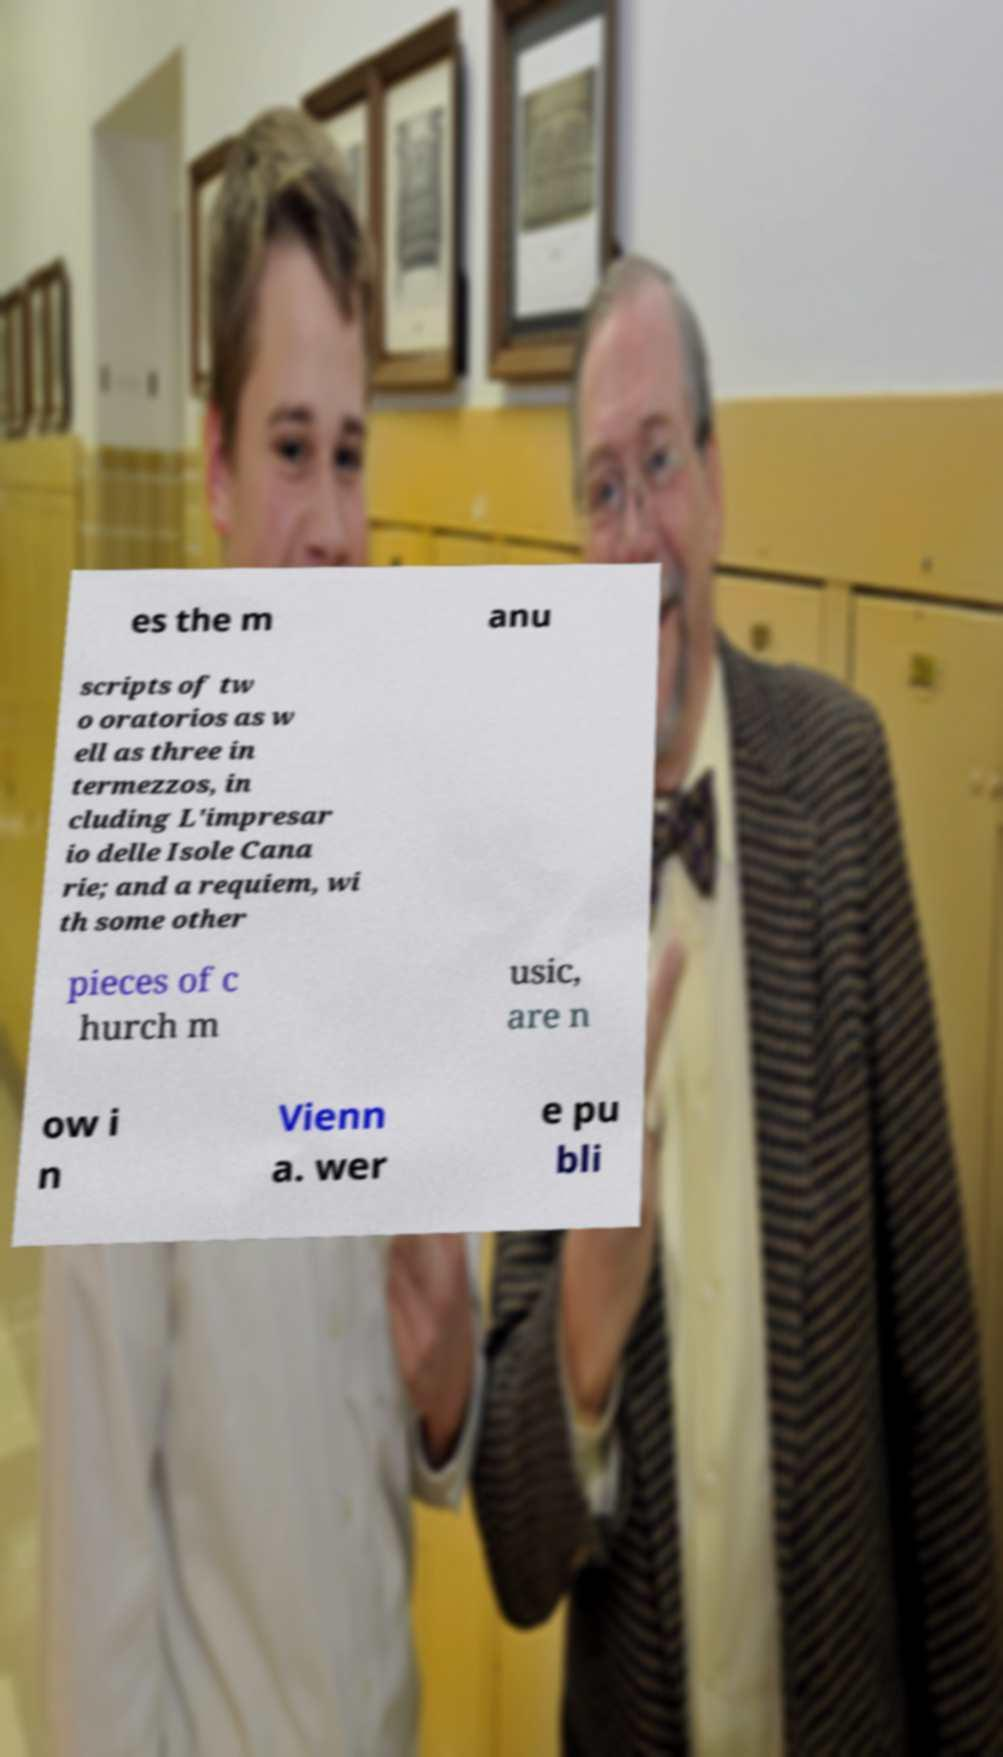Could you assist in decoding the text presented in this image and type it out clearly? es the m anu scripts of tw o oratorios as w ell as three in termezzos, in cluding L'impresar io delle Isole Cana rie; and a requiem, wi th some other pieces of c hurch m usic, are n ow i n Vienn a. wer e pu bli 